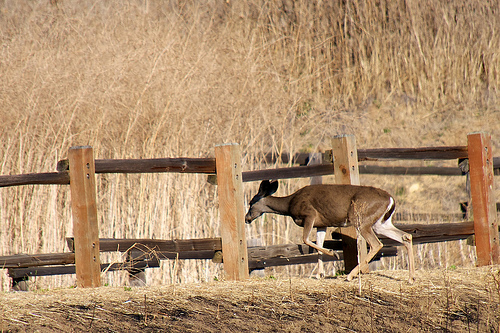<image>
Is the fence next to the animal? Yes. The fence is positioned adjacent to the animal, located nearby in the same general area. Is the deer to the left of the fence post? No. The deer is not to the left of the fence post. From this viewpoint, they have a different horizontal relationship. 